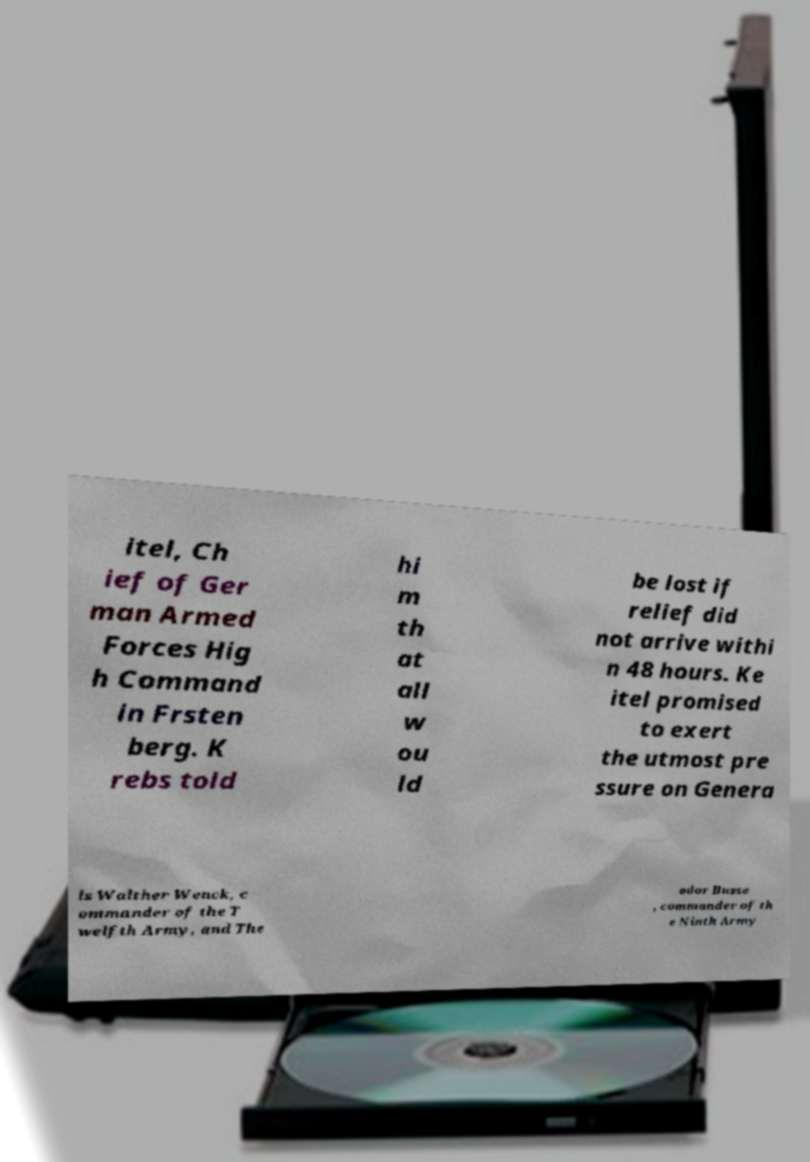There's text embedded in this image that I need extracted. Can you transcribe it verbatim? itel, Ch ief of Ger man Armed Forces Hig h Command in Frsten berg. K rebs told hi m th at all w ou ld be lost if relief did not arrive withi n 48 hours. Ke itel promised to exert the utmost pre ssure on Genera ls Walther Wenck, c ommander of the T welfth Army, and The odor Busse , commander of th e Ninth Army 